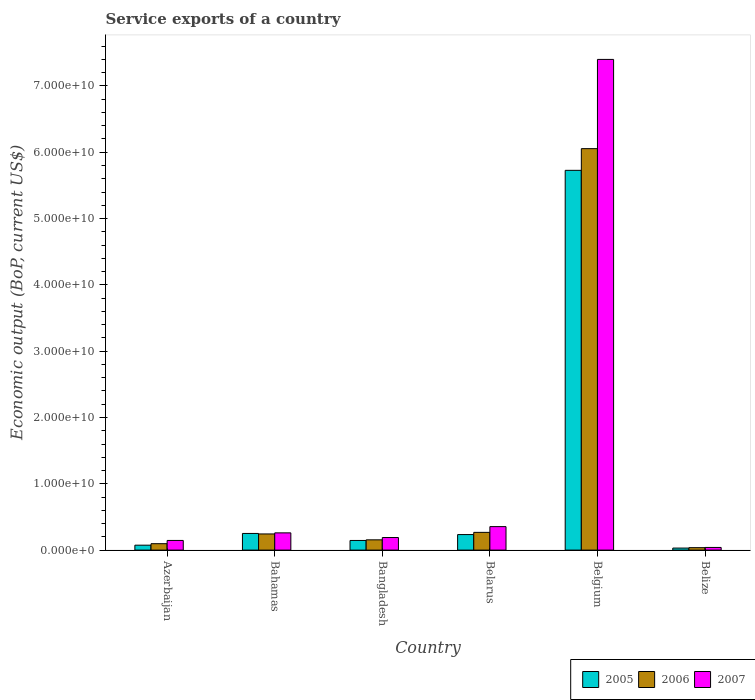How many different coloured bars are there?
Offer a terse response. 3. Are the number of bars on each tick of the X-axis equal?
Provide a succinct answer. Yes. How many bars are there on the 1st tick from the right?
Provide a succinct answer. 3. In how many cases, is the number of bars for a given country not equal to the number of legend labels?
Ensure brevity in your answer.  0. What is the service exports in 2005 in Belarus?
Provide a succinct answer. 2.34e+09. Across all countries, what is the maximum service exports in 2005?
Your answer should be very brief. 5.73e+1. Across all countries, what is the minimum service exports in 2006?
Keep it short and to the point. 3.67e+08. In which country was the service exports in 2007 maximum?
Your answer should be very brief. Belgium. In which country was the service exports in 2007 minimum?
Provide a succinct answer. Belize. What is the total service exports in 2007 in the graph?
Make the answer very short. 8.39e+1. What is the difference between the service exports in 2007 in Azerbaijan and that in Belarus?
Your response must be concise. -2.09e+09. What is the difference between the service exports in 2007 in Bahamas and the service exports in 2005 in Azerbaijan?
Keep it short and to the point. 1.86e+09. What is the average service exports in 2007 per country?
Offer a terse response. 1.40e+1. What is the difference between the service exports of/in 2005 and service exports of/in 2006 in Belize?
Make the answer very short. -6.01e+07. In how many countries, is the service exports in 2007 greater than 64000000000 US$?
Your answer should be very brief. 1. What is the ratio of the service exports in 2006 in Bahamas to that in Belize?
Your answer should be compact. 6.64. Is the service exports in 2005 in Azerbaijan less than that in Belgium?
Provide a short and direct response. Yes. Is the difference between the service exports in 2005 in Bangladesh and Belarus greater than the difference between the service exports in 2006 in Bangladesh and Belarus?
Make the answer very short. Yes. What is the difference between the highest and the second highest service exports in 2006?
Offer a very short reply. 2.37e+08. What is the difference between the highest and the lowest service exports in 2005?
Your answer should be compact. 5.70e+1. In how many countries, is the service exports in 2007 greater than the average service exports in 2007 taken over all countries?
Provide a short and direct response. 1. What does the 2nd bar from the left in Bangladesh represents?
Offer a very short reply. 2006. How many bars are there?
Your answer should be compact. 18. Are all the bars in the graph horizontal?
Your response must be concise. No. What is the difference between two consecutive major ticks on the Y-axis?
Ensure brevity in your answer.  1.00e+1. Are the values on the major ticks of Y-axis written in scientific E-notation?
Offer a very short reply. Yes. Does the graph contain any zero values?
Keep it short and to the point. No. Does the graph contain grids?
Provide a short and direct response. No. Where does the legend appear in the graph?
Offer a very short reply. Bottom right. What is the title of the graph?
Provide a succinct answer. Service exports of a country. Does "1971" appear as one of the legend labels in the graph?
Offer a very short reply. No. What is the label or title of the X-axis?
Keep it short and to the point. Country. What is the label or title of the Y-axis?
Make the answer very short. Economic output (BoP, current US$). What is the Economic output (BoP, current US$) in 2005 in Azerbaijan?
Your answer should be compact. 7.41e+08. What is the Economic output (BoP, current US$) in 2006 in Azerbaijan?
Your answer should be compact. 9.65e+08. What is the Economic output (BoP, current US$) in 2007 in Azerbaijan?
Ensure brevity in your answer.  1.46e+09. What is the Economic output (BoP, current US$) of 2005 in Bahamas?
Make the answer very short. 2.51e+09. What is the Economic output (BoP, current US$) in 2006 in Bahamas?
Provide a succinct answer. 2.44e+09. What is the Economic output (BoP, current US$) in 2007 in Bahamas?
Offer a very short reply. 2.60e+09. What is the Economic output (BoP, current US$) in 2005 in Bangladesh?
Give a very brief answer. 1.45e+09. What is the Economic output (BoP, current US$) of 2006 in Bangladesh?
Your answer should be compact. 1.55e+09. What is the Economic output (BoP, current US$) in 2007 in Bangladesh?
Your answer should be compact. 1.90e+09. What is the Economic output (BoP, current US$) in 2005 in Belarus?
Your answer should be very brief. 2.34e+09. What is the Economic output (BoP, current US$) in 2006 in Belarus?
Provide a short and direct response. 2.67e+09. What is the Economic output (BoP, current US$) in 2007 in Belarus?
Provide a succinct answer. 3.54e+09. What is the Economic output (BoP, current US$) of 2005 in Belgium?
Your response must be concise. 5.73e+1. What is the Economic output (BoP, current US$) of 2006 in Belgium?
Your response must be concise. 6.05e+1. What is the Economic output (BoP, current US$) in 2007 in Belgium?
Keep it short and to the point. 7.40e+1. What is the Economic output (BoP, current US$) in 2005 in Belize?
Ensure brevity in your answer.  3.07e+08. What is the Economic output (BoP, current US$) in 2006 in Belize?
Your answer should be compact. 3.67e+08. What is the Economic output (BoP, current US$) of 2007 in Belize?
Provide a short and direct response. 4.00e+08. Across all countries, what is the maximum Economic output (BoP, current US$) of 2005?
Offer a terse response. 5.73e+1. Across all countries, what is the maximum Economic output (BoP, current US$) in 2006?
Give a very brief answer. 6.05e+1. Across all countries, what is the maximum Economic output (BoP, current US$) of 2007?
Your answer should be compact. 7.40e+1. Across all countries, what is the minimum Economic output (BoP, current US$) of 2005?
Your answer should be very brief. 3.07e+08. Across all countries, what is the minimum Economic output (BoP, current US$) of 2006?
Offer a terse response. 3.67e+08. Across all countries, what is the minimum Economic output (BoP, current US$) of 2007?
Your answer should be compact. 4.00e+08. What is the total Economic output (BoP, current US$) of 2005 in the graph?
Offer a terse response. 6.46e+1. What is the total Economic output (BoP, current US$) of 2006 in the graph?
Keep it short and to the point. 6.85e+1. What is the total Economic output (BoP, current US$) of 2007 in the graph?
Keep it short and to the point. 8.39e+1. What is the difference between the Economic output (BoP, current US$) in 2005 in Azerbaijan and that in Bahamas?
Provide a succinct answer. -1.77e+09. What is the difference between the Economic output (BoP, current US$) in 2006 in Azerbaijan and that in Bahamas?
Provide a short and direct response. -1.47e+09. What is the difference between the Economic output (BoP, current US$) in 2007 in Azerbaijan and that in Bahamas?
Provide a short and direct response. -1.14e+09. What is the difference between the Economic output (BoP, current US$) of 2005 in Azerbaijan and that in Bangladesh?
Keep it short and to the point. -7.13e+08. What is the difference between the Economic output (BoP, current US$) in 2006 in Azerbaijan and that in Bangladesh?
Provide a short and direct response. -5.84e+08. What is the difference between the Economic output (BoP, current US$) of 2007 in Azerbaijan and that in Bangladesh?
Offer a terse response. -4.42e+08. What is the difference between the Economic output (BoP, current US$) in 2005 in Azerbaijan and that in Belarus?
Keep it short and to the point. -1.60e+09. What is the difference between the Economic output (BoP, current US$) in 2006 in Azerbaijan and that in Belarus?
Give a very brief answer. -1.71e+09. What is the difference between the Economic output (BoP, current US$) of 2007 in Azerbaijan and that in Belarus?
Give a very brief answer. -2.09e+09. What is the difference between the Economic output (BoP, current US$) of 2005 in Azerbaijan and that in Belgium?
Your response must be concise. -5.65e+1. What is the difference between the Economic output (BoP, current US$) of 2006 in Azerbaijan and that in Belgium?
Give a very brief answer. -5.96e+1. What is the difference between the Economic output (BoP, current US$) of 2007 in Azerbaijan and that in Belgium?
Your answer should be compact. -7.25e+1. What is the difference between the Economic output (BoP, current US$) in 2005 in Azerbaijan and that in Belize?
Your answer should be compact. 4.35e+08. What is the difference between the Economic output (BoP, current US$) in 2006 in Azerbaijan and that in Belize?
Make the answer very short. 5.98e+08. What is the difference between the Economic output (BoP, current US$) of 2007 in Azerbaijan and that in Belize?
Provide a short and direct response. 1.06e+09. What is the difference between the Economic output (BoP, current US$) of 2005 in Bahamas and that in Bangladesh?
Offer a very short reply. 1.06e+09. What is the difference between the Economic output (BoP, current US$) of 2006 in Bahamas and that in Bangladesh?
Give a very brief answer. 8.87e+08. What is the difference between the Economic output (BoP, current US$) of 2007 in Bahamas and that in Bangladesh?
Give a very brief answer. 7.02e+08. What is the difference between the Economic output (BoP, current US$) of 2005 in Bahamas and that in Belarus?
Your response must be concise. 1.69e+08. What is the difference between the Economic output (BoP, current US$) in 2006 in Bahamas and that in Belarus?
Provide a short and direct response. -2.37e+08. What is the difference between the Economic output (BoP, current US$) in 2007 in Bahamas and that in Belarus?
Offer a terse response. -9.42e+08. What is the difference between the Economic output (BoP, current US$) of 2005 in Bahamas and that in Belgium?
Make the answer very short. -5.48e+1. What is the difference between the Economic output (BoP, current US$) in 2006 in Bahamas and that in Belgium?
Offer a terse response. -5.81e+1. What is the difference between the Economic output (BoP, current US$) of 2007 in Bahamas and that in Belgium?
Keep it short and to the point. -7.14e+1. What is the difference between the Economic output (BoP, current US$) in 2005 in Bahamas and that in Belize?
Give a very brief answer. 2.20e+09. What is the difference between the Economic output (BoP, current US$) in 2006 in Bahamas and that in Belize?
Your response must be concise. 2.07e+09. What is the difference between the Economic output (BoP, current US$) of 2007 in Bahamas and that in Belize?
Give a very brief answer. 2.20e+09. What is the difference between the Economic output (BoP, current US$) in 2005 in Bangladesh and that in Belarus?
Keep it short and to the point. -8.88e+08. What is the difference between the Economic output (BoP, current US$) in 2006 in Bangladesh and that in Belarus?
Your answer should be compact. -1.12e+09. What is the difference between the Economic output (BoP, current US$) of 2007 in Bangladesh and that in Belarus?
Give a very brief answer. -1.64e+09. What is the difference between the Economic output (BoP, current US$) of 2005 in Bangladesh and that in Belgium?
Your answer should be compact. -5.58e+1. What is the difference between the Economic output (BoP, current US$) in 2006 in Bangladesh and that in Belgium?
Offer a terse response. -5.90e+1. What is the difference between the Economic output (BoP, current US$) in 2007 in Bangladesh and that in Belgium?
Provide a succinct answer. -7.21e+1. What is the difference between the Economic output (BoP, current US$) of 2005 in Bangladesh and that in Belize?
Your response must be concise. 1.15e+09. What is the difference between the Economic output (BoP, current US$) in 2006 in Bangladesh and that in Belize?
Your response must be concise. 1.18e+09. What is the difference between the Economic output (BoP, current US$) in 2007 in Bangladesh and that in Belize?
Keep it short and to the point. 1.50e+09. What is the difference between the Economic output (BoP, current US$) in 2005 in Belarus and that in Belgium?
Your response must be concise. -5.49e+1. What is the difference between the Economic output (BoP, current US$) in 2006 in Belarus and that in Belgium?
Provide a short and direct response. -5.79e+1. What is the difference between the Economic output (BoP, current US$) in 2007 in Belarus and that in Belgium?
Your answer should be very brief. -7.05e+1. What is the difference between the Economic output (BoP, current US$) in 2005 in Belarus and that in Belize?
Offer a very short reply. 2.04e+09. What is the difference between the Economic output (BoP, current US$) of 2006 in Belarus and that in Belize?
Keep it short and to the point. 2.31e+09. What is the difference between the Economic output (BoP, current US$) in 2007 in Belarus and that in Belize?
Your answer should be very brief. 3.14e+09. What is the difference between the Economic output (BoP, current US$) of 2005 in Belgium and that in Belize?
Keep it short and to the point. 5.70e+1. What is the difference between the Economic output (BoP, current US$) of 2006 in Belgium and that in Belize?
Your answer should be compact. 6.02e+1. What is the difference between the Economic output (BoP, current US$) in 2007 in Belgium and that in Belize?
Provide a succinct answer. 7.36e+1. What is the difference between the Economic output (BoP, current US$) in 2005 in Azerbaijan and the Economic output (BoP, current US$) in 2006 in Bahamas?
Your answer should be compact. -1.69e+09. What is the difference between the Economic output (BoP, current US$) in 2005 in Azerbaijan and the Economic output (BoP, current US$) in 2007 in Bahamas?
Provide a succinct answer. -1.86e+09. What is the difference between the Economic output (BoP, current US$) in 2006 in Azerbaijan and the Economic output (BoP, current US$) in 2007 in Bahamas?
Offer a terse response. -1.63e+09. What is the difference between the Economic output (BoP, current US$) in 2005 in Azerbaijan and the Economic output (BoP, current US$) in 2006 in Bangladesh?
Ensure brevity in your answer.  -8.08e+08. What is the difference between the Economic output (BoP, current US$) of 2005 in Azerbaijan and the Economic output (BoP, current US$) of 2007 in Bangladesh?
Give a very brief answer. -1.16e+09. What is the difference between the Economic output (BoP, current US$) in 2006 in Azerbaijan and the Economic output (BoP, current US$) in 2007 in Bangladesh?
Offer a terse response. -9.32e+08. What is the difference between the Economic output (BoP, current US$) of 2005 in Azerbaijan and the Economic output (BoP, current US$) of 2006 in Belarus?
Offer a terse response. -1.93e+09. What is the difference between the Economic output (BoP, current US$) of 2005 in Azerbaijan and the Economic output (BoP, current US$) of 2007 in Belarus?
Keep it short and to the point. -2.80e+09. What is the difference between the Economic output (BoP, current US$) of 2006 in Azerbaijan and the Economic output (BoP, current US$) of 2007 in Belarus?
Keep it short and to the point. -2.58e+09. What is the difference between the Economic output (BoP, current US$) in 2005 in Azerbaijan and the Economic output (BoP, current US$) in 2006 in Belgium?
Provide a succinct answer. -5.98e+1. What is the difference between the Economic output (BoP, current US$) in 2005 in Azerbaijan and the Economic output (BoP, current US$) in 2007 in Belgium?
Offer a terse response. -7.33e+1. What is the difference between the Economic output (BoP, current US$) of 2006 in Azerbaijan and the Economic output (BoP, current US$) of 2007 in Belgium?
Make the answer very short. -7.30e+1. What is the difference between the Economic output (BoP, current US$) of 2005 in Azerbaijan and the Economic output (BoP, current US$) of 2006 in Belize?
Keep it short and to the point. 3.74e+08. What is the difference between the Economic output (BoP, current US$) in 2005 in Azerbaijan and the Economic output (BoP, current US$) in 2007 in Belize?
Your answer should be very brief. 3.41e+08. What is the difference between the Economic output (BoP, current US$) in 2006 in Azerbaijan and the Economic output (BoP, current US$) in 2007 in Belize?
Your answer should be compact. 5.65e+08. What is the difference between the Economic output (BoP, current US$) in 2005 in Bahamas and the Economic output (BoP, current US$) in 2006 in Bangladesh?
Provide a short and direct response. 9.62e+08. What is the difference between the Economic output (BoP, current US$) of 2005 in Bahamas and the Economic output (BoP, current US$) of 2007 in Bangladesh?
Your response must be concise. 6.14e+08. What is the difference between the Economic output (BoP, current US$) of 2006 in Bahamas and the Economic output (BoP, current US$) of 2007 in Bangladesh?
Keep it short and to the point. 5.39e+08. What is the difference between the Economic output (BoP, current US$) of 2005 in Bahamas and the Economic output (BoP, current US$) of 2006 in Belarus?
Offer a terse response. -1.63e+08. What is the difference between the Economic output (BoP, current US$) of 2005 in Bahamas and the Economic output (BoP, current US$) of 2007 in Belarus?
Provide a succinct answer. -1.03e+09. What is the difference between the Economic output (BoP, current US$) of 2006 in Bahamas and the Economic output (BoP, current US$) of 2007 in Belarus?
Offer a very short reply. -1.11e+09. What is the difference between the Economic output (BoP, current US$) of 2005 in Bahamas and the Economic output (BoP, current US$) of 2006 in Belgium?
Provide a succinct answer. -5.80e+1. What is the difference between the Economic output (BoP, current US$) in 2005 in Bahamas and the Economic output (BoP, current US$) in 2007 in Belgium?
Keep it short and to the point. -7.15e+1. What is the difference between the Economic output (BoP, current US$) in 2006 in Bahamas and the Economic output (BoP, current US$) in 2007 in Belgium?
Provide a succinct answer. -7.16e+1. What is the difference between the Economic output (BoP, current US$) of 2005 in Bahamas and the Economic output (BoP, current US$) of 2006 in Belize?
Ensure brevity in your answer.  2.14e+09. What is the difference between the Economic output (BoP, current US$) of 2005 in Bahamas and the Economic output (BoP, current US$) of 2007 in Belize?
Provide a short and direct response. 2.11e+09. What is the difference between the Economic output (BoP, current US$) of 2006 in Bahamas and the Economic output (BoP, current US$) of 2007 in Belize?
Give a very brief answer. 2.04e+09. What is the difference between the Economic output (BoP, current US$) in 2005 in Bangladesh and the Economic output (BoP, current US$) in 2006 in Belarus?
Your answer should be compact. -1.22e+09. What is the difference between the Economic output (BoP, current US$) of 2005 in Bangladesh and the Economic output (BoP, current US$) of 2007 in Belarus?
Make the answer very short. -2.09e+09. What is the difference between the Economic output (BoP, current US$) of 2006 in Bangladesh and the Economic output (BoP, current US$) of 2007 in Belarus?
Your response must be concise. -1.99e+09. What is the difference between the Economic output (BoP, current US$) of 2005 in Bangladesh and the Economic output (BoP, current US$) of 2006 in Belgium?
Your response must be concise. -5.91e+1. What is the difference between the Economic output (BoP, current US$) in 2005 in Bangladesh and the Economic output (BoP, current US$) in 2007 in Belgium?
Your answer should be very brief. -7.25e+1. What is the difference between the Economic output (BoP, current US$) of 2006 in Bangladesh and the Economic output (BoP, current US$) of 2007 in Belgium?
Offer a terse response. -7.25e+1. What is the difference between the Economic output (BoP, current US$) of 2005 in Bangladesh and the Economic output (BoP, current US$) of 2006 in Belize?
Give a very brief answer. 1.09e+09. What is the difference between the Economic output (BoP, current US$) of 2005 in Bangladesh and the Economic output (BoP, current US$) of 2007 in Belize?
Offer a very short reply. 1.05e+09. What is the difference between the Economic output (BoP, current US$) of 2006 in Bangladesh and the Economic output (BoP, current US$) of 2007 in Belize?
Your answer should be very brief. 1.15e+09. What is the difference between the Economic output (BoP, current US$) of 2005 in Belarus and the Economic output (BoP, current US$) of 2006 in Belgium?
Offer a terse response. -5.82e+1. What is the difference between the Economic output (BoP, current US$) in 2005 in Belarus and the Economic output (BoP, current US$) in 2007 in Belgium?
Keep it short and to the point. -7.17e+1. What is the difference between the Economic output (BoP, current US$) in 2006 in Belarus and the Economic output (BoP, current US$) in 2007 in Belgium?
Offer a terse response. -7.13e+1. What is the difference between the Economic output (BoP, current US$) of 2005 in Belarus and the Economic output (BoP, current US$) of 2006 in Belize?
Your answer should be compact. 1.98e+09. What is the difference between the Economic output (BoP, current US$) of 2005 in Belarus and the Economic output (BoP, current US$) of 2007 in Belize?
Provide a short and direct response. 1.94e+09. What is the difference between the Economic output (BoP, current US$) in 2006 in Belarus and the Economic output (BoP, current US$) in 2007 in Belize?
Your answer should be very brief. 2.27e+09. What is the difference between the Economic output (BoP, current US$) of 2005 in Belgium and the Economic output (BoP, current US$) of 2006 in Belize?
Your answer should be very brief. 5.69e+1. What is the difference between the Economic output (BoP, current US$) in 2005 in Belgium and the Economic output (BoP, current US$) in 2007 in Belize?
Offer a terse response. 5.69e+1. What is the difference between the Economic output (BoP, current US$) of 2006 in Belgium and the Economic output (BoP, current US$) of 2007 in Belize?
Offer a terse response. 6.01e+1. What is the average Economic output (BoP, current US$) of 2005 per country?
Keep it short and to the point. 1.08e+1. What is the average Economic output (BoP, current US$) of 2006 per country?
Provide a short and direct response. 1.14e+1. What is the average Economic output (BoP, current US$) in 2007 per country?
Your response must be concise. 1.40e+1. What is the difference between the Economic output (BoP, current US$) in 2005 and Economic output (BoP, current US$) in 2006 in Azerbaijan?
Your answer should be compact. -2.24e+08. What is the difference between the Economic output (BoP, current US$) of 2005 and Economic output (BoP, current US$) of 2007 in Azerbaijan?
Give a very brief answer. -7.14e+08. What is the difference between the Economic output (BoP, current US$) of 2006 and Economic output (BoP, current US$) of 2007 in Azerbaijan?
Keep it short and to the point. -4.90e+08. What is the difference between the Economic output (BoP, current US$) of 2005 and Economic output (BoP, current US$) of 2006 in Bahamas?
Provide a short and direct response. 7.48e+07. What is the difference between the Economic output (BoP, current US$) of 2005 and Economic output (BoP, current US$) of 2007 in Bahamas?
Your answer should be compact. -8.84e+07. What is the difference between the Economic output (BoP, current US$) in 2006 and Economic output (BoP, current US$) in 2007 in Bahamas?
Offer a very short reply. -1.63e+08. What is the difference between the Economic output (BoP, current US$) in 2005 and Economic output (BoP, current US$) in 2006 in Bangladesh?
Your answer should be very brief. -9.44e+07. What is the difference between the Economic output (BoP, current US$) of 2005 and Economic output (BoP, current US$) of 2007 in Bangladesh?
Offer a very short reply. -4.43e+08. What is the difference between the Economic output (BoP, current US$) of 2006 and Economic output (BoP, current US$) of 2007 in Bangladesh?
Your response must be concise. -3.48e+08. What is the difference between the Economic output (BoP, current US$) in 2005 and Economic output (BoP, current US$) in 2006 in Belarus?
Your answer should be compact. -3.31e+08. What is the difference between the Economic output (BoP, current US$) of 2005 and Economic output (BoP, current US$) of 2007 in Belarus?
Provide a short and direct response. -1.20e+09. What is the difference between the Economic output (BoP, current US$) of 2006 and Economic output (BoP, current US$) of 2007 in Belarus?
Offer a very short reply. -8.68e+08. What is the difference between the Economic output (BoP, current US$) in 2005 and Economic output (BoP, current US$) in 2006 in Belgium?
Your answer should be compact. -3.27e+09. What is the difference between the Economic output (BoP, current US$) in 2005 and Economic output (BoP, current US$) in 2007 in Belgium?
Your response must be concise. -1.67e+1. What is the difference between the Economic output (BoP, current US$) of 2006 and Economic output (BoP, current US$) of 2007 in Belgium?
Ensure brevity in your answer.  -1.35e+1. What is the difference between the Economic output (BoP, current US$) in 2005 and Economic output (BoP, current US$) in 2006 in Belize?
Your answer should be compact. -6.01e+07. What is the difference between the Economic output (BoP, current US$) in 2005 and Economic output (BoP, current US$) in 2007 in Belize?
Your answer should be very brief. -9.31e+07. What is the difference between the Economic output (BoP, current US$) in 2006 and Economic output (BoP, current US$) in 2007 in Belize?
Your response must be concise. -3.31e+07. What is the ratio of the Economic output (BoP, current US$) of 2005 in Azerbaijan to that in Bahamas?
Make the answer very short. 0.3. What is the ratio of the Economic output (BoP, current US$) of 2006 in Azerbaijan to that in Bahamas?
Your answer should be compact. 0.4. What is the ratio of the Economic output (BoP, current US$) of 2007 in Azerbaijan to that in Bahamas?
Keep it short and to the point. 0.56. What is the ratio of the Economic output (BoP, current US$) in 2005 in Azerbaijan to that in Bangladesh?
Keep it short and to the point. 0.51. What is the ratio of the Economic output (BoP, current US$) of 2006 in Azerbaijan to that in Bangladesh?
Provide a short and direct response. 0.62. What is the ratio of the Economic output (BoP, current US$) in 2007 in Azerbaijan to that in Bangladesh?
Offer a terse response. 0.77. What is the ratio of the Economic output (BoP, current US$) in 2005 in Azerbaijan to that in Belarus?
Offer a terse response. 0.32. What is the ratio of the Economic output (BoP, current US$) in 2006 in Azerbaijan to that in Belarus?
Your response must be concise. 0.36. What is the ratio of the Economic output (BoP, current US$) in 2007 in Azerbaijan to that in Belarus?
Your answer should be very brief. 0.41. What is the ratio of the Economic output (BoP, current US$) of 2005 in Azerbaijan to that in Belgium?
Provide a succinct answer. 0.01. What is the ratio of the Economic output (BoP, current US$) in 2006 in Azerbaijan to that in Belgium?
Offer a terse response. 0.02. What is the ratio of the Economic output (BoP, current US$) in 2007 in Azerbaijan to that in Belgium?
Offer a terse response. 0.02. What is the ratio of the Economic output (BoP, current US$) of 2005 in Azerbaijan to that in Belize?
Your answer should be very brief. 2.42. What is the ratio of the Economic output (BoP, current US$) in 2006 in Azerbaijan to that in Belize?
Your answer should be compact. 2.63. What is the ratio of the Economic output (BoP, current US$) in 2007 in Azerbaijan to that in Belize?
Make the answer very short. 3.64. What is the ratio of the Economic output (BoP, current US$) in 2005 in Bahamas to that in Bangladesh?
Offer a very short reply. 1.73. What is the ratio of the Economic output (BoP, current US$) of 2006 in Bahamas to that in Bangladesh?
Provide a succinct answer. 1.57. What is the ratio of the Economic output (BoP, current US$) in 2007 in Bahamas to that in Bangladesh?
Give a very brief answer. 1.37. What is the ratio of the Economic output (BoP, current US$) in 2005 in Bahamas to that in Belarus?
Make the answer very short. 1.07. What is the ratio of the Economic output (BoP, current US$) of 2006 in Bahamas to that in Belarus?
Keep it short and to the point. 0.91. What is the ratio of the Economic output (BoP, current US$) in 2007 in Bahamas to that in Belarus?
Make the answer very short. 0.73. What is the ratio of the Economic output (BoP, current US$) in 2005 in Bahamas to that in Belgium?
Give a very brief answer. 0.04. What is the ratio of the Economic output (BoP, current US$) in 2006 in Bahamas to that in Belgium?
Make the answer very short. 0.04. What is the ratio of the Economic output (BoP, current US$) of 2007 in Bahamas to that in Belgium?
Give a very brief answer. 0.04. What is the ratio of the Economic output (BoP, current US$) in 2005 in Bahamas to that in Belize?
Your answer should be compact. 8.18. What is the ratio of the Economic output (BoP, current US$) of 2006 in Bahamas to that in Belize?
Provide a succinct answer. 6.64. What is the ratio of the Economic output (BoP, current US$) of 2007 in Bahamas to that in Belize?
Keep it short and to the point. 6.5. What is the ratio of the Economic output (BoP, current US$) of 2005 in Bangladesh to that in Belarus?
Your response must be concise. 0.62. What is the ratio of the Economic output (BoP, current US$) in 2006 in Bangladesh to that in Belarus?
Give a very brief answer. 0.58. What is the ratio of the Economic output (BoP, current US$) of 2007 in Bangladesh to that in Belarus?
Ensure brevity in your answer.  0.54. What is the ratio of the Economic output (BoP, current US$) of 2005 in Bangladesh to that in Belgium?
Provide a short and direct response. 0.03. What is the ratio of the Economic output (BoP, current US$) in 2006 in Bangladesh to that in Belgium?
Provide a succinct answer. 0.03. What is the ratio of the Economic output (BoP, current US$) of 2007 in Bangladesh to that in Belgium?
Your answer should be very brief. 0.03. What is the ratio of the Economic output (BoP, current US$) in 2005 in Bangladesh to that in Belize?
Give a very brief answer. 4.74. What is the ratio of the Economic output (BoP, current US$) of 2006 in Bangladesh to that in Belize?
Keep it short and to the point. 4.22. What is the ratio of the Economic output (BoP, current US$) of 2007 in Bangladesh to that in Belize?
Make the answer very short. 4.74. What is the ratio of the Economic output (BoP, current US$) in 2005 in Belarus to that in Belgium?
Provide a succinct answer. 0.04. What is the ratio of the Economic output (BoP, current US$) in 2006 in Belarus to that in Belgium?
Offer a terse response. 0.04. What is the ratio of the Economic output (BoP, current US$) of 2007 in Belarus to that in Belgium?
Your answer should be compact. 0.05. What is the ratio of the Economic output (BoP, current US$) in 2005 in Belarus to that in Belize?
Offer a very short reply. 7.63. What is the ratio of the Economic output (BoP, current US$) in 2006 in Belarus to that in Belize?
Offer a terse response. 7.28. What is the ratio of the Economic output (BoP, current US$) in 2007 in Belarus to that in Belize?
Provide a short and direct response. 8.85. What is the ratio of the Economic output (BoP, current US$) in 2005 in Belgium to that in Belize?
Provide a succinct answer. 186.58. What is the ratio of the Economic output (BoP, current US$) of 2006 in Belgium to that in Belize?
Offer a terse response. 164.95. What is the ratio of the Economic output (BoP, current US$) in 2007 in Belgium to that in Belize?
Give a very brief answer. 184.96. What is the difference between the highest and the second highest Economic output (BoP, current US$) of 2005?
Ensure brevity in your answer.  5.48e+1. What is the difference between the highest and the second highest Economic output (BoP, current US$) in 2006?
Offer a terse response. 5.79e+1. What is the difference between the highest and the second highest Economic output (BoP, current US$) of 2007?
Your response must be concise. 7.05e+1. What is the difference between the highest and the lowest Economic output (BoP, current US$) of 2005?
Provide a succinct answer. 5.70e+1. What is the difference between the highest and the lowest Economic output (BoP, current US$) of 2006?
Make the answer very short. 6.02e+1. What is the difference between the highest and the lowest Economic output (BoP, current US$) of 2007?
Provide a succinct answer. 7.36e+1. 